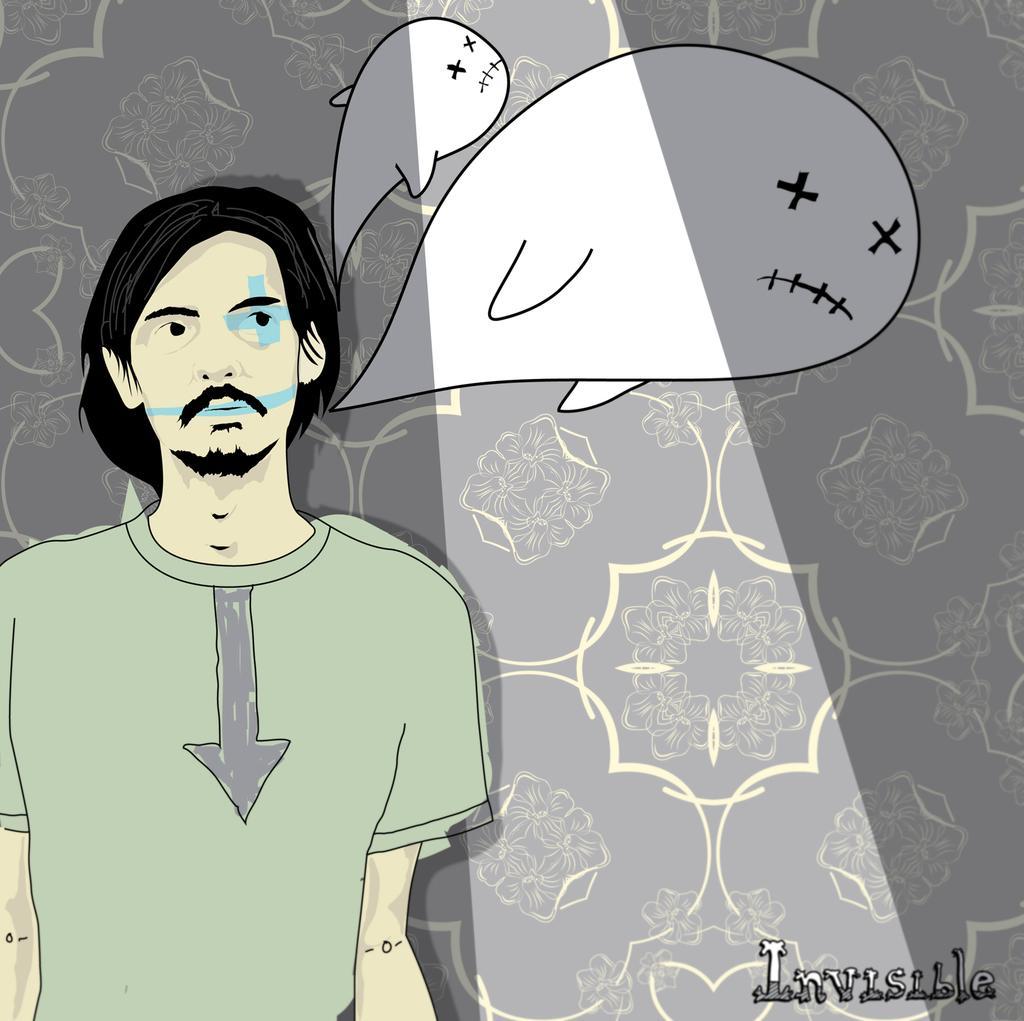Please provide a concise description of this image. In this picture we observe a cartoon image of a guy who is thinking of dolphins and there is a watermark down the image named as INVISIBLE. 